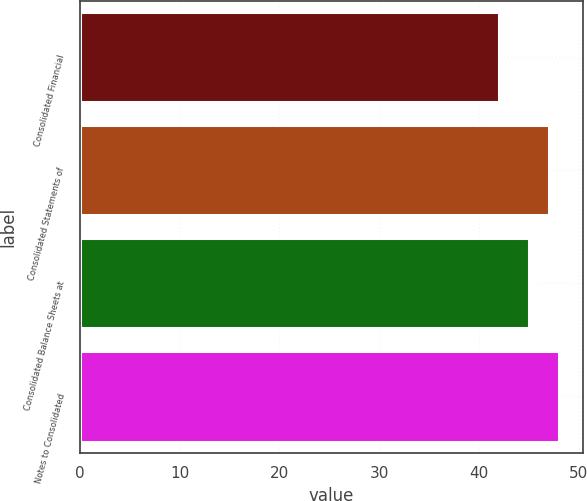<chart> <loc_0><loc_0><loc_500><loc_500><bar_chart><fcel>Consolidated Financial<fcel>Consolidated Statements of<fcel>Consolidated Balance Sheets at<fcel>Notes to Consolidated<nl><fcel>42<fcel>47<fcel>45<fcel>48<nl></chart> 